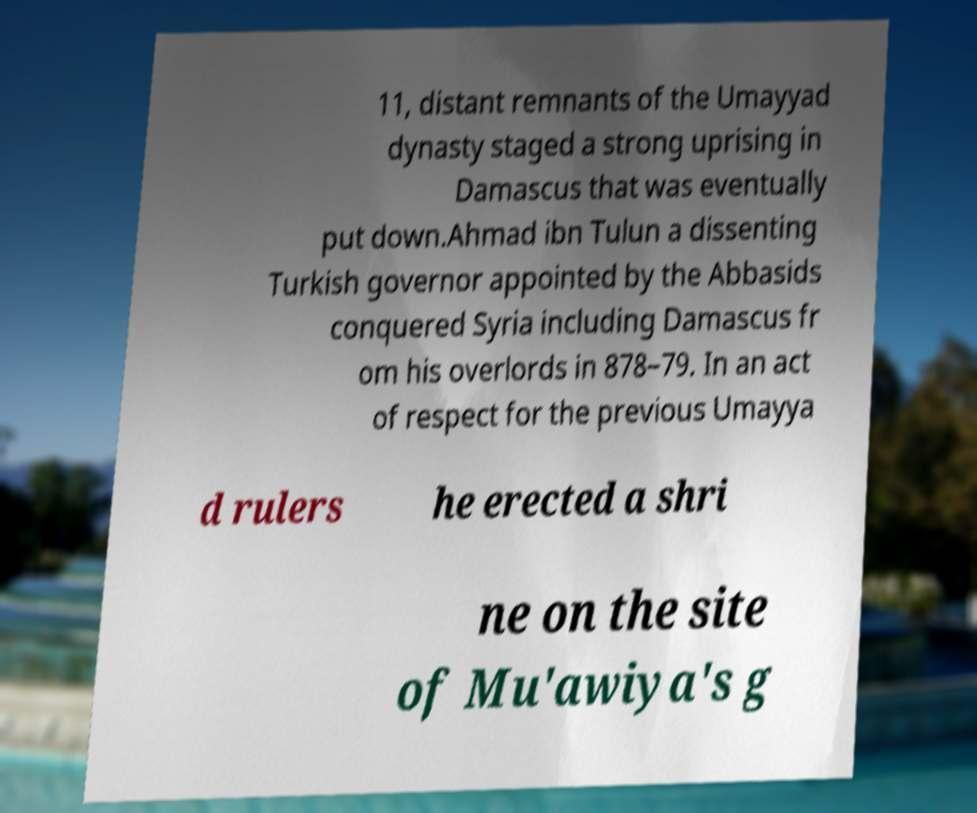What messages or text are displayed in this image? I need them in a readable, typed format. 11, distant remnants of the Umayyad dynasty staged a strong uprising in Damascus that was eventually put down.Ahmad ibn Tulun a dissenting Turkish governor appointed by the Abbasids conquered Syria including Damascus fr om his overlords in 878–79. In an act of respect for the previous Umayya d rulers he erected a shri ne on the site of Mu'awiya's g 